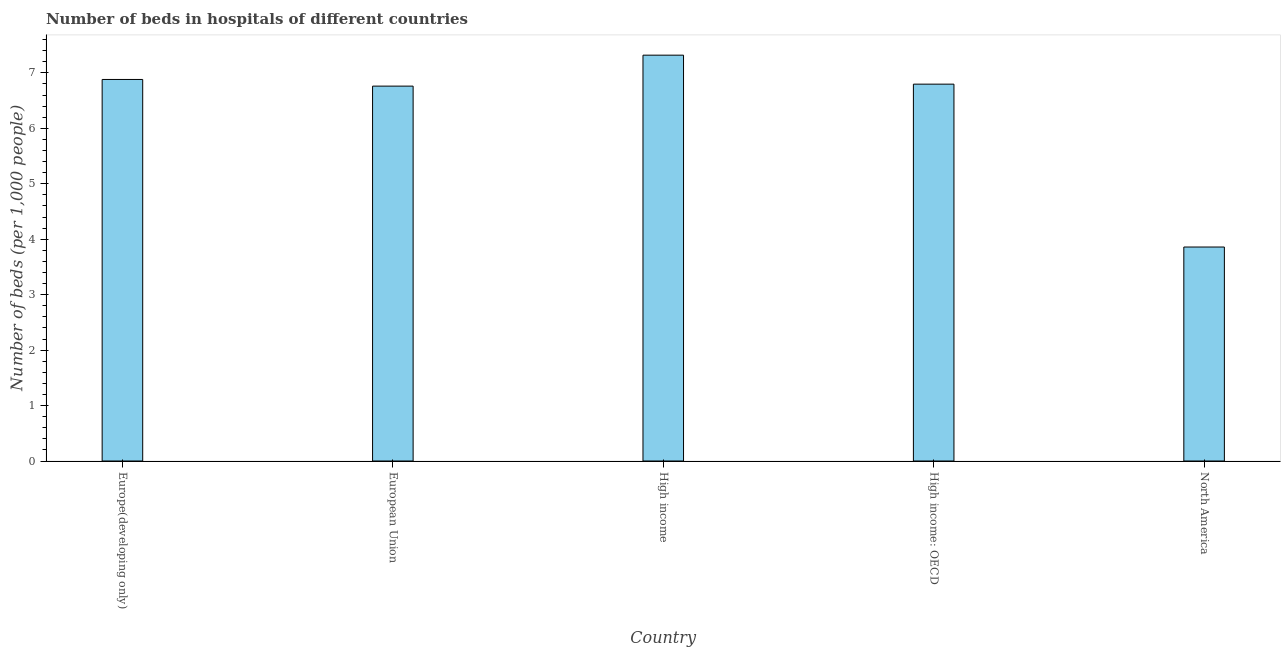Does the graph contain grids?
Make the answer very short. No. What is the title of the graph?
Your answer should be very brief. Number of beds in hospitals of different countries. What is the label or title of the Y-axis?
Ensure brevity in your answer.  Number of beds (per 1,0 people). What is the number of hospital beds in North America?
Your response must be concise. 3.86. Across all countries, what is the maximum number of hospital beds?
Give a very brief answer. 7.32. Across all countries, what is the minimum number of hospital beds?
Give a very brief answer. 3.86. In which country was the number of hospital beds maximum?
Offer a very short reply. High income. What is the sum of the number of hospital beds?
Your response must be concise. 31.62. What is the difference between the number of hospital beds in High income and North America?
Offer a very short reply. 3.46. What is the average number of hospital beds per country?
Provide a short and direct response. 6.32. What is the median number of hospital beds?
Offer a terse response. 6.8. What is the ratio of the number of hospital beds in High income: OECD to that in North America?
Provide a short and direct response. 1.76. Is the number of hospital beds in High income less than that in High income: OECD?
Your answer should be very brief. No. What is the difference between the highest and the second highest number of hospital beds?
Offer a terse response. 0.44. Is the sum of the number of hospital beds in Europe(developing only) and European Union greater than the maximum number of hospital beds across all countries?
Keep it short and to the point. Yes. What is the difference between the highest and the lowest number of hospital beds?
Provide a short and direct response. 3.46. In how many countries, is the number of hospital beds greater than the average number of hospital beds taken over all countries?
Ensure brevity in your answer.  4. How many bars are there?
Your answer should be very brief. 5. How many countries are there in the graph?
Ensure brevity in your answer.  5. Are the values on the major ticks of Y-axis written in scientific E-notation?
Offer a terse response. No. What is the Number of beds (per 1,000 people) of Europe(developing only)?
Offer a terse response. 6.88. What is the Number of beds (per 1,000 people) in European Union?
Offer a very short reply. 6.76. What is the Number of beds (per 1,000 people) in High income?
Offer a terse response. 7.32. What is the Number of beds (per 1,000 people) in High income: OECD?
Offer a terse response. 6.8. What is the Number of beds (per 1,000 people) in North America?
Keep it short and to the point. 3.86. What is the difference between the Number of beds (per 1,000 people) in Europe(developing only) and European Union?
Offer a very short reply. 0.12. What is the difference between the Number of beds (per 1,000 people) in Europe(developing only) and High income?
Your answer should be very brief. -0.44. What is the difference between the Number of beds (per 1,000 people) in Europe(developing only) and High income: OECD?
Offer a terse response. 0.08. What is the difference between the Number of beds (per 1,000 people) in Europe(developing only) and North America?
Your answer should be very brief. 3.02. What is the difference between the Number of beds (per 1,000 people) in European Union and High income?
Make the answer very short. -0.56. What is the difference between the Number of beds (per 1,000 people) in European Union and High income: OECD?
Ensure brevity in your answer.  -0.04. What is the difference between the Number of beds (per 1,000 people) in European Union and North America?
Give a very brief answer. 2.9. What is the difference between the Number of beds (per 1,000 people) in High income and High income: OECD?
Your response must be concise. 0.52. What is the difference between the Number of beds (per 1,000 people) in High income and North America?
Make the answer very short. 3.46. What is the difference between the Number of beds (per 1,000 people) in High income: OECD and North America?
Provide a succinct answer. 2.94. What is the ratio of the Number of beds (per 1,000 people) in Europe(developing only) to that in European Union?
Provide a short and direct response. 1.02. What is the ratio of the Number of beds (per 1,000 people) in Europe(developing only) to that in North America?
Offer a very short reply. 1.78. What is the ratio of the Number of beds (per 1,000 people) in European Union to that in High income?
Your response must be concise. 0.92. What is the ratio of the Number of beds (per 1,000 people) in European Union to that in High income: OECD?
Keep it short and to the point. 0.99. What is the ratio of the Number of beds (per 1,000 people) in European Union to that in North America?
Ensure brevity in your answer.  1.75. What is the ratio of the Number of beds (per 1,000 people) in High income to that in High income: OECD?
Offer a very short reply. 1.08. What is the ratio of the Number of beds (per 1,000 people) in High income to that in North America?
Your answer should be very brief. 1.9. What is the ratio of the Number of beds (per 1,000 people) in High income: OECD to that in North America?
Your response must be concise. 1.76. 